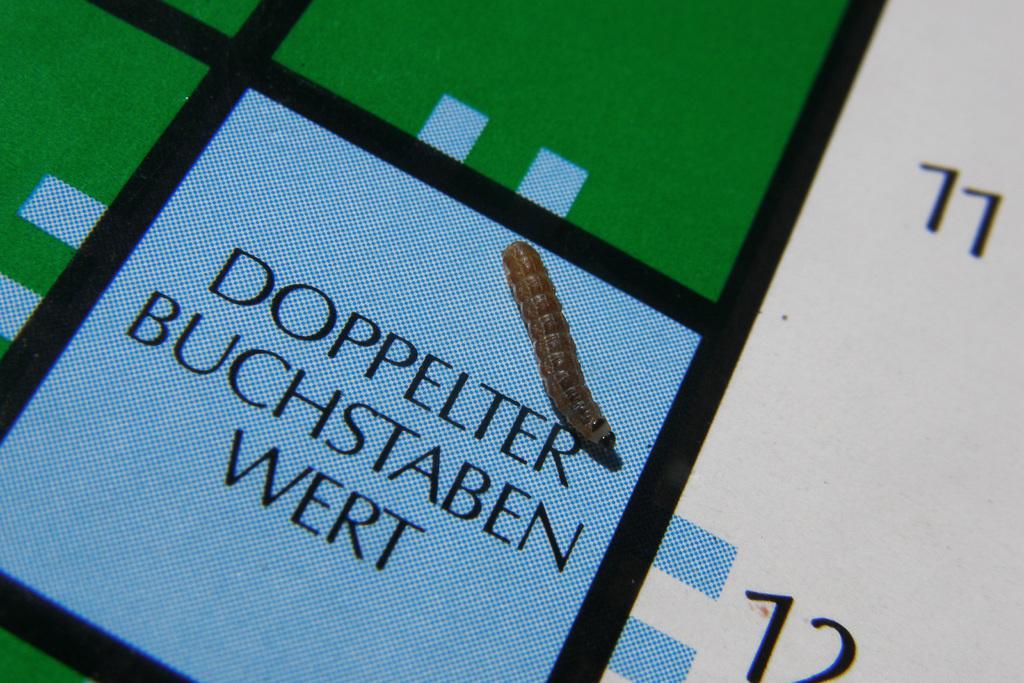Could you give a brief overview of what you see in this image? In the image there is an insect on a printed surface. 